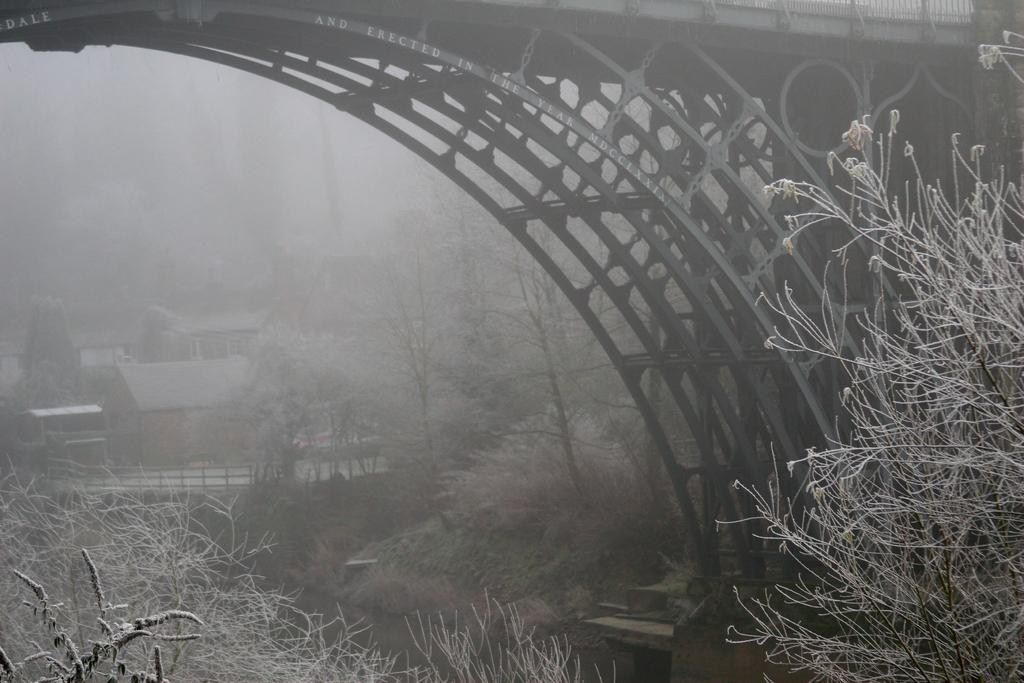What is at the bottom of the image? There is water at the bottom of the image. What can be seen on either side of the image? There are trees on either side of the image. What structure is visible on the right side of the image? There appears to be a bridge on the right side of the image. What type of buildings can be seen in the background of the image? There are houses visible in the background of the image. How many clouds are present in the image? There are no clouds mentioned in the provided facts, so it cannot be determined how many clouds are present in the image. 